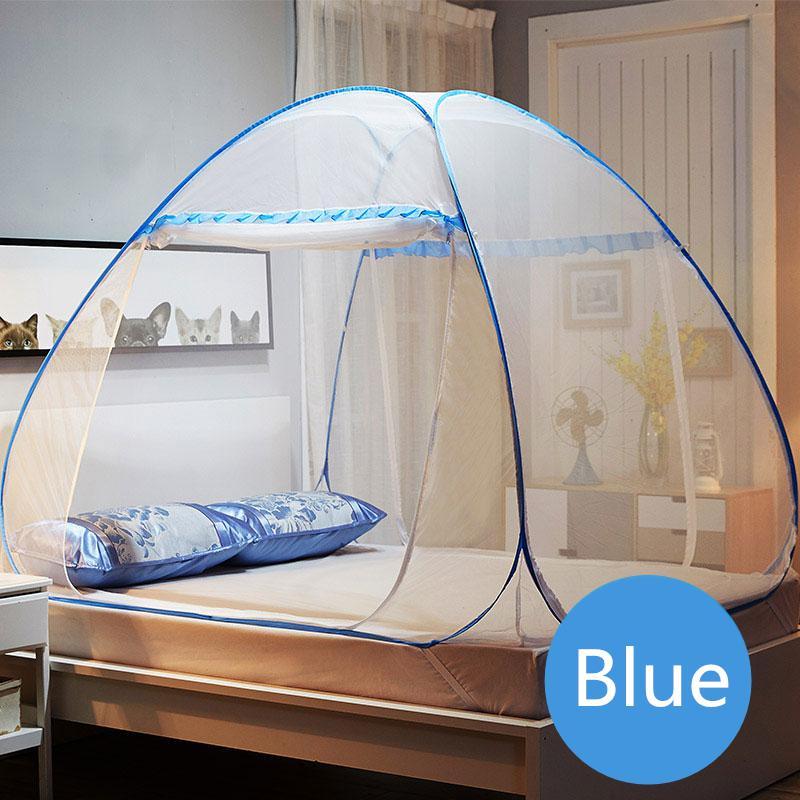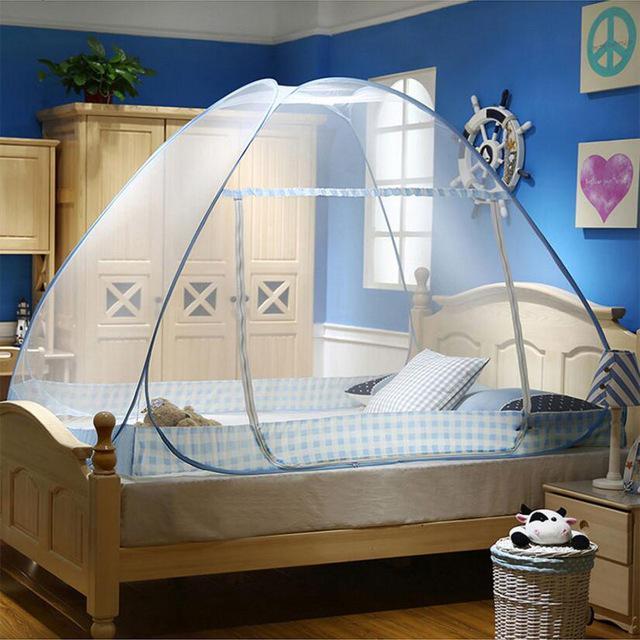The first image is the image on the left, the second image is the image on the right. Examine the images to the left and right. Is the description "A bed canopy has a checkered fabric strip around the bottom." accurate? Answer yes or no. Yes. The first image is the image on the left, the second image is the image on the right. Examine the images to the left and right. Is the description "There is artwork on the wall behind the bed in the right image." accurate? Answer yes or no. Yes. 